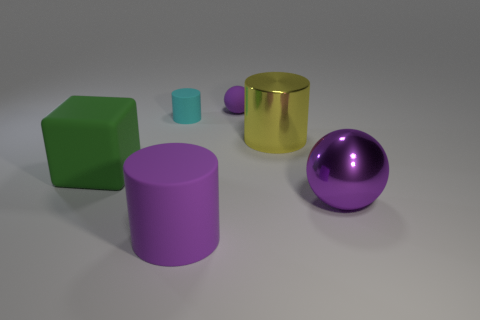The shiny ball that is the same color as the large rubber cylinder is what size?
Keep it short and to the point. Large. What shape is the purple metal object on the right side of the purple rubber ball?
Offer a very short reply. Sphere. How many other things are the same size as the cyan cylinder?
Your answer should be compact. 1. Does the large matte thing that is right of the small cyan object have the same shape as the big purple object on the right side of the matte ball?
Your answer should be compact. No. There is a cyan matte cylinder; how many big purple things are on the right side of it?
Provide a succinct answer. 2. The sphere in front of the large yellow object is what color?
Your answer should be very brief. Purple. There is another big rubber thing that is the same shape as the big yellow thing; what is its color?
Your response must be concise. Purple. Is there anything else of the same color as the block?
Keep it short and to the point. No. Is the number of balls greater than the number of tiny cyan shiny objects?
Offer a terse response. Yes. Are the yellow cylinder and the small cylinder made of the same material?
Make the answer very short. No. 